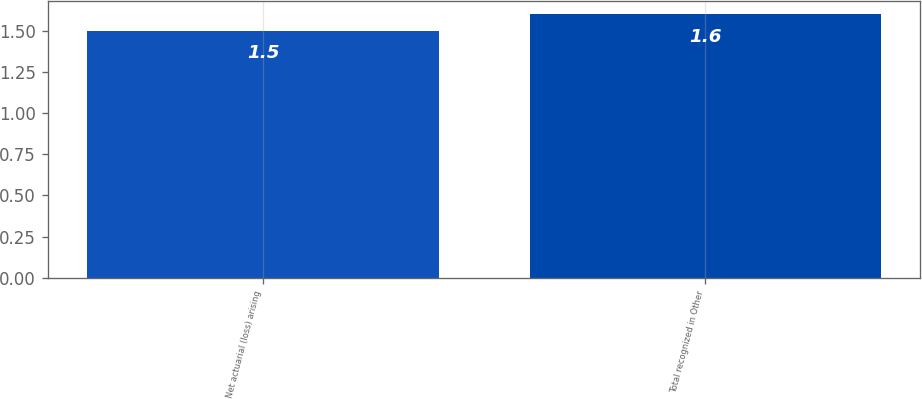Convert chart. <chart><loc_0><loc_0><loc_500><loc_500><bar_chart><fcel>Net actuarial (loss) arising<fcel>Total recognized in Other<nl><fcel>1.5<fcel>1.6<nl></chart> 